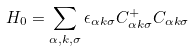Convert formula to latex. <formula><loc_0><loc_0><loc_500><loc_500>H _ { 0 } = \sum _ { \alpha , k , \sigma } \epsilon _ { \alpha k \sigma } C _ { \alpha k \sigma } ^ { + } C _ { \alpha k \sigma }</formula> 